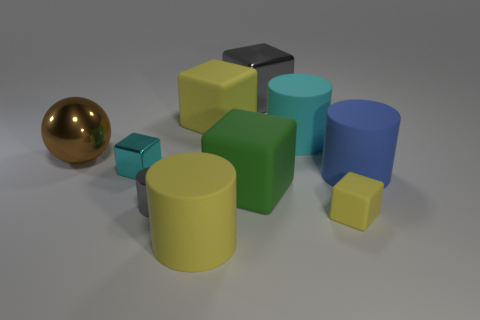Subtract all cyan rubber cylinders. How many cylinders are left? 3 Subtract all yellow cylinders. How many cylinders are left? 3 Subtract all yellow cylinders. How many yellow blocks are left? 2 Subtract 1 spheres. How many spheres are left? 0 Add 2 cyan rubber objects. How many cyan rubber objects are left? 3 Add 4 large cylinders. How many large cylinders exist? 7 Subtract 0 green spheres. How many objects are left? 10 Subtract all spheres. How many objects are left? 9 Subtract all red blocks. Subtract all blue cylinders. How many blocks are left? 5 Subtract all purple matte cylinders. Subtract all large cyan objects. How many objects are left? 9 